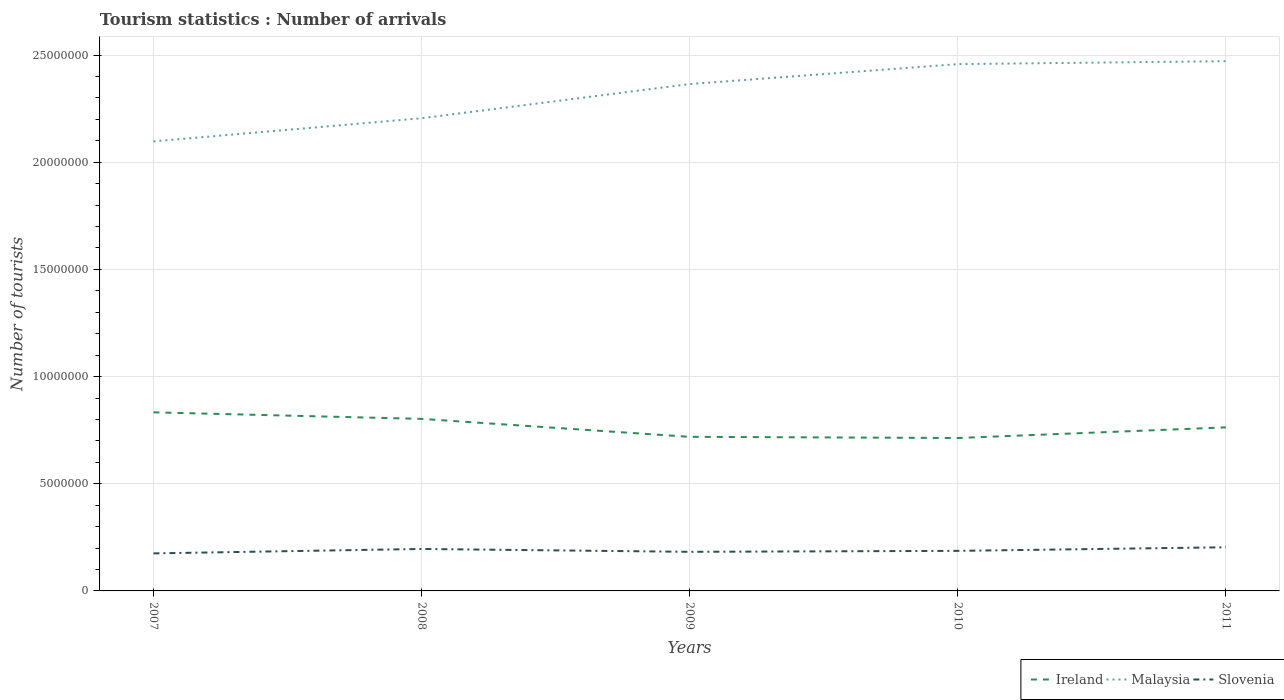Across all years, what is the maximum number of tourist arrivals in Slovenia?
Provide a succinct answer. 1.75e+06. What is the total number of tourist arrivals in Malaysia in the graph?
Ensure brevity in your answer.  -2.66e+06. What is the difference between the highest and the second highest number of tourist arrivals in Malaysia?
Offer a very short reply. 3.74e+06. How many lines are there?
Make the answer very short. 3. Does the graph contain grids?
Make the answer very short. Yes. Where does the legend appear in the graph?
Offer a terse response. Bottom right. How many legend labels are there?
Offer a very short reply. 3. What is the title of the graph?
Offer a very short reply. Tourism statistics : Number of arrivals. What is the label or title of the X-axis?
Give a very brief answer. Years. What is the label or title of the Y-axis?
Give a very brief answer. Number of tourists. What is the Number of tourists of Ireland in 2007?
Offer a very short reply. 8.33e+06. What is the Number of tourists in Malaysia in 2007?
Provide a succinct answer. 2.10e+07. What is the Number of tourists of Slovenia in 2007?
Offer a terse response. 1.75e+06. What is the Number of tourists in Ireland in 2008?
Keep it short and to the point. 8.03e+06. What is the Number of tourists in Malaysia in 2008?
Provide a succinct answer. 2.21e+07. What is the Number of tourists in Slovenia in 2008?
Give a very brief answer. 1.96e+06. What is the Number of tourists in Ireland in 2009?
Provide a succinct answer. 7.19e+06. What is the Number of tourists of Malaysia in 2009?
Keep it short and to the point. 2.36e+07. What is the Number of tourists of Slovenia in 2009?
Keep it short and to the point. 1.82e+06. What is the Number of tourists in Ireland in 2010?
Make the answer very short. 7.13e+06. What is the Number of tourists in Malaysia in 2010?
Make the answer very short. 2.46e+07. What is the Number of tourists of Slovenia in 2010?
Offer a terse response. 1.87e+06. What is the Number of tourists of Ireland in 2011?
Provide a succinct answer. 7.63e+06. What is the Number of tourists in Malaysia in 2011?
Your response must be concise. 2.47e+07. What is the Number of tourists in Slovenia in 2011?
Offer a terse response. 2.04e+06. Across all years, what is the maximum Number of tourists in Ireland?
Keep it short and to the point. 8.33e+06. Across all years, what is the maximum Number of tourists in Malaysia?
Keep it short and to the point. 2.47e+07. Across all years, what is the maximum Number of tourists of Slovenia?
Keep it short and to the point. 2.04e+06. Across all years, what is the minimum Number of tourists of Ireland?
Provide a succinct answer. 7.13e+06. Across all years, what is the minimum Number of tourists of Malaysia?
Your answer should be very brief. 2.10e+07. Across all years, what is the minimum Number of tourists in Slovenia?
Provide a succinct answer. 1.75e+06. What is the total Number of tourists in Ireland in the graph?
Offer a terse response. 3.83e+07. What is the total Number of tourists of Malaysia in the graph?
Offer a very short reply. 1.16e+08. What is the total Number of tourists of Slovenia in the graph?
Ensure brevity in your answer.  9.44e+06. What is the difference between the Number of tourists of Ireland in 2007 and that in 2008?
Provide a succinct answer. 3.06e+05. What is the difference between the Number of tourists of Malaysia in 2007 and that in 2008?
Ensure brevity in your answer.  -1.08e+06. What is the difference between the Number of tourists in Slovenia in 2007 and that in 2008?
Offer a very short reply. -2.07e+05. What is the difference between the Number of tourists in Ireland in 2007 and that in 2009?
Your response must be concise. 1.14e+06. What is the difference between the Number of tourists in Malaysia in 2007 and that in 2009?
Provide a short and direct response. -2.67e+06. What is the difference between the Number of tourists of Slovenia in 2007 and that in 2009?
Provide a short and direct response. -7.30e+04. What is the difference between the Number of tourists of Ireland in 2007 and that in 2010?
Your answer should be compact. 1.20e+06. What is the difference between the Number of tourists of Malaysia in 2007 and that in 2010?
Your response must be concise. -3.60e+06. What is the difference between the Number of tourists in Slovenia in 2007 and that in 2010?
Ensure brevity in your answer.  -1.18e+05. What is the difference between the Number of tourists in Ireland in 2007 and that in 2011?
Make the answer very short. 7.02e+05. What is the difference between the Number of tourists in Malaysia in 2007 and that in 2011?
Offer a terse response. -3.74e+06. What is the difference between the Number of tourists in Slovenia in 2007 and that in 2011?
Your response must be concise. -2.86e+05. What is the difference between the Number of tourists of Ireland in 2008 and that in 2009?
Offer a terse response. 8.37e+05. What is the difference between the Number of tourists in Malaysia in 2008 and that in 2009?
Make the answer very short. -1.59e+06. What is the difference between the Number of tourists of Slovenia in 2008 and that in 2009?
Your response must be concise. 1.34e+05. What is the difference between the Number of tourists of Ireland in 2008 and that in 2010?
Make the answer very short. 8.92e+05. What is the difference between the Number of tourists of Malaysia in 2008 and that in 2010?
Your response must be concise. -2.52e+06. What is the difference between the Number of tourists in Slovenia in 2008 and that in 2010?
Ensure brevity in your answer.  8.90e+04. What is the difference between the Number of tourists of Ireland in 2008 and that in 2011?
Make the answer very short. 3.96e+05. What is the difference between the Number of tourists in Malaysia in 2008 and that in 2011?
Give a very brief answer. -2.66e+06. What is the difference between the Number of tourists of Slovenia in 2008 and that in 2011?
Make the answer very short. -7.90e+04. What is the difference between the Number of tourists of Ireland in 2009 and that in 2010?
Your response must be concise. 5.50e+04. What is the difference between the Number of tourists of Malaysia in 2009 and that in 2010?
Give a very brief answer. -9.31e+05. What is the difference between the Number of tourists of Slovenia in 2009 and that in 2010?
Provide a succinct answer. -4.50e+04. What is the difference between the Number of tourists of Ireland in 2009 and that in 2011?
Your response must be concise. -4.41e+05. What is the difference between the Number of tourists in Malaysia in 2009 and that in 2011?
Your answer should be compact. -1.07e+06. What is the difference between the Number of tourists in Slovenia in 2009 and that in 2011?
Offer a very short reply. -2.13e+05. What is the difference between the Number of tourists of Ireland in 2010 and that in 2011?
Make the answer very short. -4.96e+05. What is the difference between the Number of tourists in Malaysia in 2010 and that in 2011?
Ensure brevity in your answer.  -1.37e+05. What is the difference between the Number of tourists of Slovenia in 2010 and that in 2011?
Offer a very short reply. -1.68e+05. What is the difference between the Number of tourists of Ireland in 2007 and the Number of tourists of Malaysia in 2008?
Your response must be concise. -1.37e+07. What is the difference between the Number of tourists in Ireland in 2007 and the Number of tourists in Slovenia in 2008?
Give a very brief answer. 6.37e+06. What is the difference between the Number of tourists in Malaysia in 2007 and the Number of tourists in Slovenia in 2008?
Offer a terse response. 1.90e+07. What is the difference between the Number of tourists of Ireland in 2007 and the Number of tourists of Malaysia in 2009?
Ensure brevity in your answer.  -1.53e+07. What is the difference between the Number of tourists of Ireland in 2007 and the Number of tourists of Slovenia in 2009?
Your answer should be compact. 6.51e+06. What is the difference between the Number of tourists in Malaysia in 2007 and the Number of tourists in Slovenia in 2009?
Your answer should be very brief. 1.91e+07. What is the difference between the Number of tourists in Ireland in 2007 and the Number of tourists in Malaysia in 2010?
Your response must be concise. -1.62e+07. What is the difference between the Number of tourists of Ireland in 2007 and the Number of tourists of Slovenia in 2010?
Provide a short and direct response. 6.46e+06. What is the difference between the Number of tourists in Malaysia in 2007 and the Number of tourists in Slovenia in 2010?
Offer a very short reply. 1.91e+07. What is the difference between the Number of tourists in Ireland in 2007 and the Number of tourists in Malaysia in 2011?
Your answer should be very brief. -1.64e+07. What is the difference between the Number of tourists in Ireland in 2007 and the Number of tourists in Slovenia in 2011?
Your response must be concise. 6.30e+06. What is the difference between the Number of tourists in Malaysia in 2007 and the Number of tourists in Slovenia in 2011?
Ensure brevity in your answer.  1.89e+07. What is the difference between the Number of tourists of Ireland in 2008 and the Number of tourists of Malaysia in 2009?
Provide a succinct answer. -1.56e+07. What is the difference between the Number of tourists in Ireland in 2008 and the Number of tourists in Slovenia in 2009?
Your answer should be compact. 6.20e+06. What is the difference between the Number of tourists in Malaysia in 2008 and the Number of tourists in Slovenia in 2009?
Provide a short and direct response. 2.02e+07. What is the difference between the Number of tourists of Ireland in 2008 and the Number of tourists of Malaysia in 2010?
Offer a terse response. -1.66e+07. What is the difference between the Number of tourists in Ireland in 2008 and the Number of tourists in Slovenia in 2010?
Offer a very short reply. 6.16e+06. What is the difference between the Number of tourists in Malaysia in 2008 and the Number of tourists in Slovenia in 2010?
Make the answer very short. 2.02e+07. What is the difference between the Number of tourists of Ireland in 2008 and the Number of tourists of Malaysia in 2011?
Give a very brief answer. -1.67e+07. What is the difference between the Number of tourists in Ireland in 2008 and the Number of tourists in Slovenia in 2011?
Keep it short and to the point. 5.99e+06. What is the difference between the Number of tourists in Malaysia in 2008 and the Number of tourists in Slovenia in 2011?
Your answer should be very brief. 2.00e+07. What is the difference between the Number of tourists in Ireland in 2009 and the Number of tourists in Malaysia in 2010?
Offer a terse response. -1.74e+07. What is the difference between the Number of tourists of Ireland in 2009 and the Number of tourists of Slovenia in 2010?
Provide a short and direct response. 5.32e+06. What is the difference between the Number of tourists of Malaysia in 2009 and the Number of tourists of Slovenia in 2010?
Provide a succinct answer. 2.18e+07. What is the difference between the Number of tourists in Ireland in 2009 and the Number of tourists in Malaysia in 2011?
Your response must be concise. -1.75e+07. What is the difference between the Number of tourists in Ireland in 2009 and the Number of tourists in Slovenia in 2011?
Offer a very short reply. 5.15e+06. What is the difference between the Number of tourists of Malaysia in 2009 and the Number of tourists of Slovenia in 2011?
Offer a terse response. 2.16e+07. What is the difference between the Number of tourists in Ireland in 2010 and the Number of tourists in Malaysia in 2011?
Your response must be concise. -1.76e+07. What is the difference between the Number of tourists in Ireland in 2010 and the Number of tourists in Slovenia in 2011?
Your response must be concise. 5.10e+06. What is the difference between the Number of tourists of Malaysia in 2010 and the Number of tourists of Slovenia in 2011?
Give a very brief answer. 2.25e+07. What is the average Number of tourists of Ireland per year?
Your response must be concise. 7.66e+06. What is the average Number of tourists of Malaysia per year?
Provide a short and direct response. 2.32e+07. What is the average Number of tourists in Slovenia per year?
Ensure brevity in your answer.  1.89e+06. In the year 2007, what is the difference between the Number of tourists in Ireland and Number of tourists in Malaysia?
Offer a very short reply. -1.26e+07. In the year 2007, what is the difference between the Number of tourists of Ireland and Number of tourists of Slovenia?
Provide a short and direct response. 6.58e+06. In the year 2007, what is the difference between the Number of tourists of Malaysia and Number of tourists of Slovenia?
Provide a short and direct response. 1.92e+07. In the year 2008, what is the difference between the Number of tourists of Ireland and Number of tourists of Malaysia?
Offer a terse response. -1.40e+07. In the year 2008, what is the difference between the Number of tourists in Ireland and Number of tourists in Slovenia?
Give a very brief answer. 6.07e+06. In the year 2008, what is the difference between the Number of tourists in Malaysia and Number of tourists in Slovenia?
Give a very brief answer. 2.01e+07. In the year 2009, what is the difference between the Number of tourists of Ireland and Number of tourists of Malaysia?
Give a very brief answer. -1.65e+07. In the year 2009, what is the difference between the Number of tourists in Ireland and Number of tourists in Slovenia?
Your answer should be compact. 5.36e+06. In the year 2009, what is the difference between the Number of tourists in Malaysia and Number of tourists in Slovenia?
Your answer should be compact. 2.18e+07. In the year 2010, what is the difference between the Number of tourists of Ireland and Number of tourists of Malaysia?
Offer a terse response. -1.74e+07. In the year 2010, what is the difference between the Number of tourists of Ireland and Number of tourists of Slovenia?
Give a very brief answer. 5.26e+06. In the year 2010, what is the difference between the Number of tourists of Malaysia and Number of tourists of Slovenia?
Offer a terse response. 2.27e+07. In the year 2011, what is the difference between the Number of tourists in Ireland and Number of tourists in Malaysia?
Make the answer very short. -1.71e+07. In the year 2011, what is the difference between the Number of tourists in Ireland and Number of tourists in Slovenia?
Provide a short and direct response. 5.59e+06. In the year 2011, what is the difference between the Number of tourists in Malaysia and Number of tourists in Slovenia?
Provide a short and direct response. 2.27e+07. What is the ratio of the Number of tourists of Ireland in 2007 to that in 2008?
Your answer should be very brief. 1.04. What is the ratio of the Number of tourists in Malaysia in 2007 to that in 2008?
Your response must be concise. 0.95. What is the ratio of the Number of tourists in Slovenia in 2007 to that in 2008?
Give a very brief answer. 0.89. What is the ratio of the Number of tourists in Ireland in 2007 to that in 2009?
Provide a succinct answer. 1.16. What is the ratio of the Number of tourists in Malaysia in 2007 to that in 2009?
Keep it short and to the point. 0.89. What is the ratio of the Number of tourists in Ireland in 2007 to that in 2010?
Provide a short and direct response. 1.17. What is the ratio of the Number of tourists in Malaysia in 2007 to that in 2010?
Ensure brevity in your answer.  0.85. What is the ratio of the Number of tourists of Slovenia in 2007 to that in 2010?
Give a very brief answer. 0.94. What is the ratio of the Number of tourists in Ireland in 2007 to that in 2011?
Your answer should be very brief. 1.09. What is the ratio of the Number of tourists of Malaysia in 2007 to that in 2011?
Your answer should be very brief. 0.85. What is the ratio of the Number of tourists of Slovenia in 2007 to that in 2011?
Ensure brevity in your answer.  0.86. What is the ratio of the Number of tourists of Ireland in 2008 to that in 2009?
Keep it short and to the point. 1.12. What is the ratio of the Number of tourists in Malaysia in 2008 to that in 2009?
Your answer should be compact. 0.93. What is the ratio of the Number of tourists of Slovenia in 2008 to that in 2009?
Your answer should be compact. 1.07. What is the ratio of the Number of tourists in Malaysia in 2008 to that in 2010?
Your response must be concise. 0.9. What is the ratio of the Number of tourists of Slovenia in 2008 to that in 2010?
Your answer should be compact. 1.05. What is the ratio of the Number of tourists in Ireland in 2008 to that in 2011?
Make the answer very short. 1.05. What is the ratio of the Number of tourists of Malaysia in 2008 to that in 2011?
Provide a succinct answer. 0.89. What is the ratio of the Number of tourists in Slovenia in 2008 to that in 2011?
Offer a terse response. 0.96. What is the ratio of the Number of tourists of Ireland in 2009 to that in 2010?
Make the answer very short. 1.01. What is the ratio of the Number of tourists of Malaysia in 2009 to that in 2010?
Your response must be concise. 0.96. What is the ratio of the Number of tourists in Slovenia in 2009 to that in 2010?
Your answer should be compact. 0.98. What is the ratio of the Number of tourists of Ireland in 2009 to that in 2011?
Your answer should be compact. 0.94. What is the ratio of the Number of tourists in Malaysia in 2009 to that in 2011?
Your response must be concise. 0.96. What is the ratio of the Number of tourists in Slovenia in 2009 to that in 2011?
Your answer should be very brief. 0.9. What is the ratio of the Number of tourists of Ireland in 2010 to that in 2011?
Keep it short and to the point. 0.94. What is the ratio of the Number of tourists in Slovenia in 2010 to that in 2011?
Provide a succinct answer. 0.92. What is the difference between the highest and the second highest Number of tourists in Ireland?
Make the answer very short. 3.06e+05. What is the difference between the highest and the second highest Number of tourists of Malaysia?
Give a very brief answer. 1.37e+05. What is the difference between the highest and the second highest Number of tourists in Slovenia?
Give a very brief answer. 7.90e+04. What is the difference between the highest and the lowest Number of tourists in Ireland?
Your response must be concise. 1.20e+06. What is the difference between the highest and the lowest Number of tourists in Malaysia?
Give a very brief answer. 3.74e+06. What is the difference between the highest and the lowest Number of tourists in Slovenia?
Your response must be concise. 2.86e+05. 